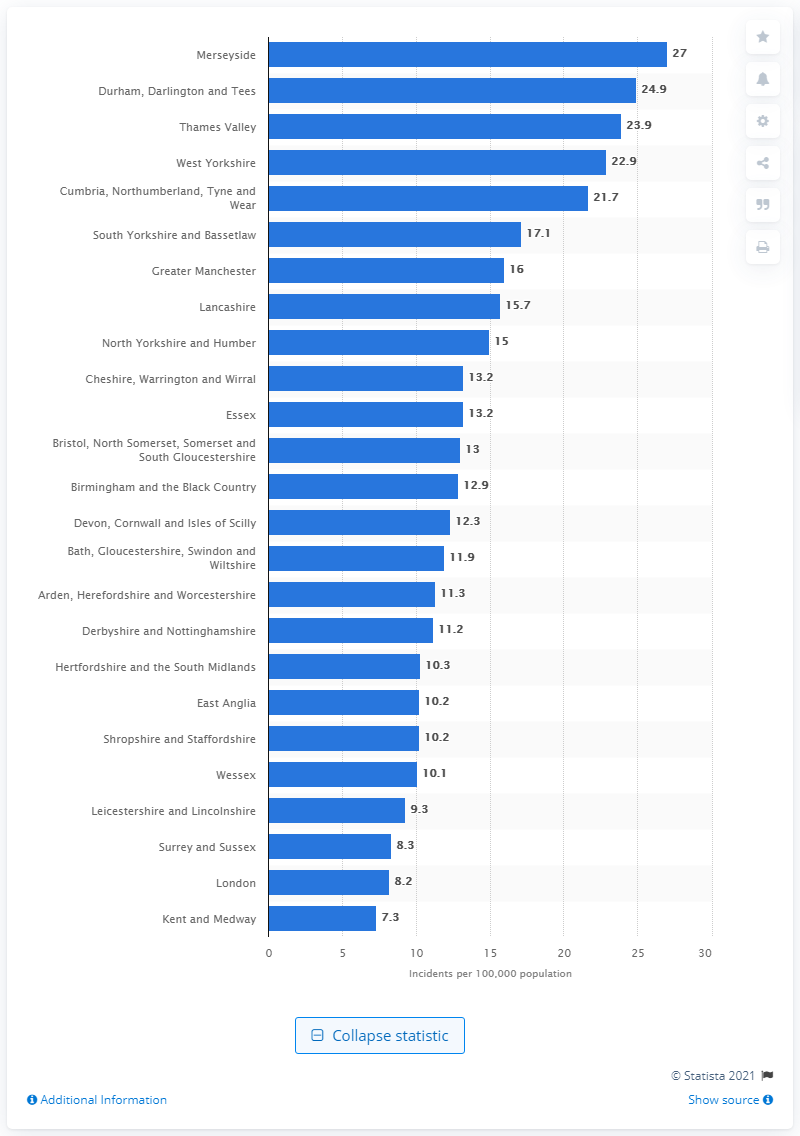Outline some significant characteristics in this image. Merseyside had the highest incidence of dog bites among all areas in the United Kingdom. 